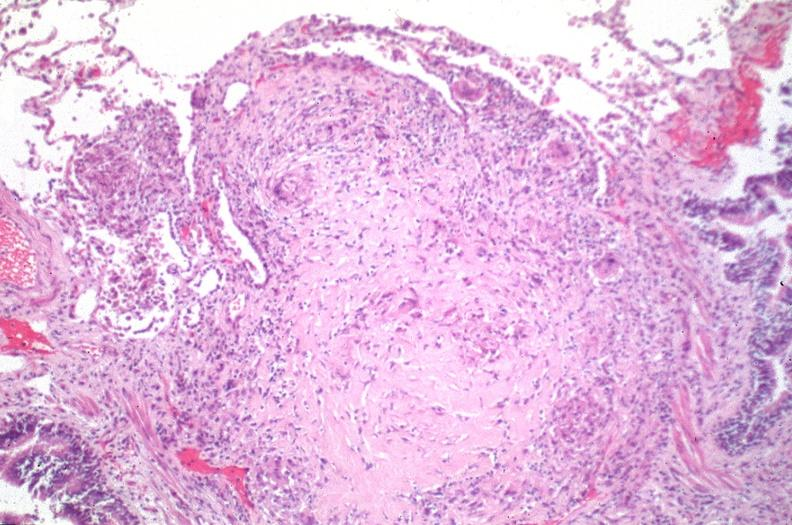s respiratory present?
Answer the question using a single word or phrase. Yes 